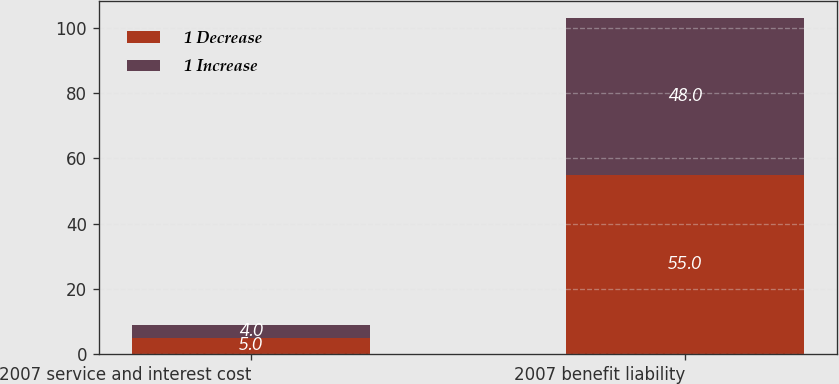Convert chart to OTSL. <chart><loc_0><loc_0><loc_500><loc_500><stacked_bar_chart><ecel><fcel>2007 service and interest cost<fcel>2007 benefit liability<nl><fcel>1 Decrease<fcel>5<fcel>55<nl><fcel>1 Increase<fcel>4<fcel>48<nl></chart> 